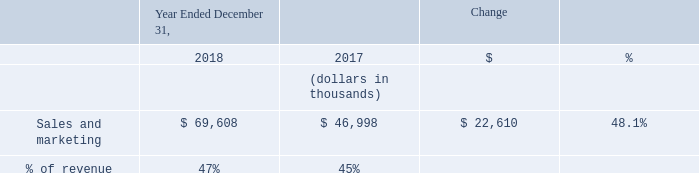Sales and Marketing Expense
Sales and marketing expense increased by $22.6 million in 2018 compared to 2017. The increase was primarily due to a $20.0 million increase in employee- related costs, which includes stock-based compensation, associated with our increased headcount from 215 employees as of December 31, 2017 to 286 employees as of December 31, 2018. The remaining increase was principally the result of a $1.8 million increase in trade show and advertising costs and a $0.8 million increase attributed to office related expenses to support the sales team. The adoption of ASC 606 did not have a material impact on the change in commission expense when compared to year over year.
What was the increase in the Sales and marketing expense in 2018 compared to 2017? $22.6 million. What was the Sales and marketing expense in 2018 and 2017? 69,608, 46,998. What is the % change in the sales and marketing expense between 2017 and 2018?
Answer scale should be: percent. 48.1. What is the average Sales and marketing expense for 2017 and 2018?
Answer scale should be: thousand. (69,608 + 46,998) / 2
Answer: 58303. In which year was Sales and marketing expenses less than 50,000 thousands? Locate and analyze sales and marketing in row 4
answer: 2017. What is the change in the gross margin between 2017 and 2018?
Answer scale should be: thousand. 47 - 45
Answer: 2. 